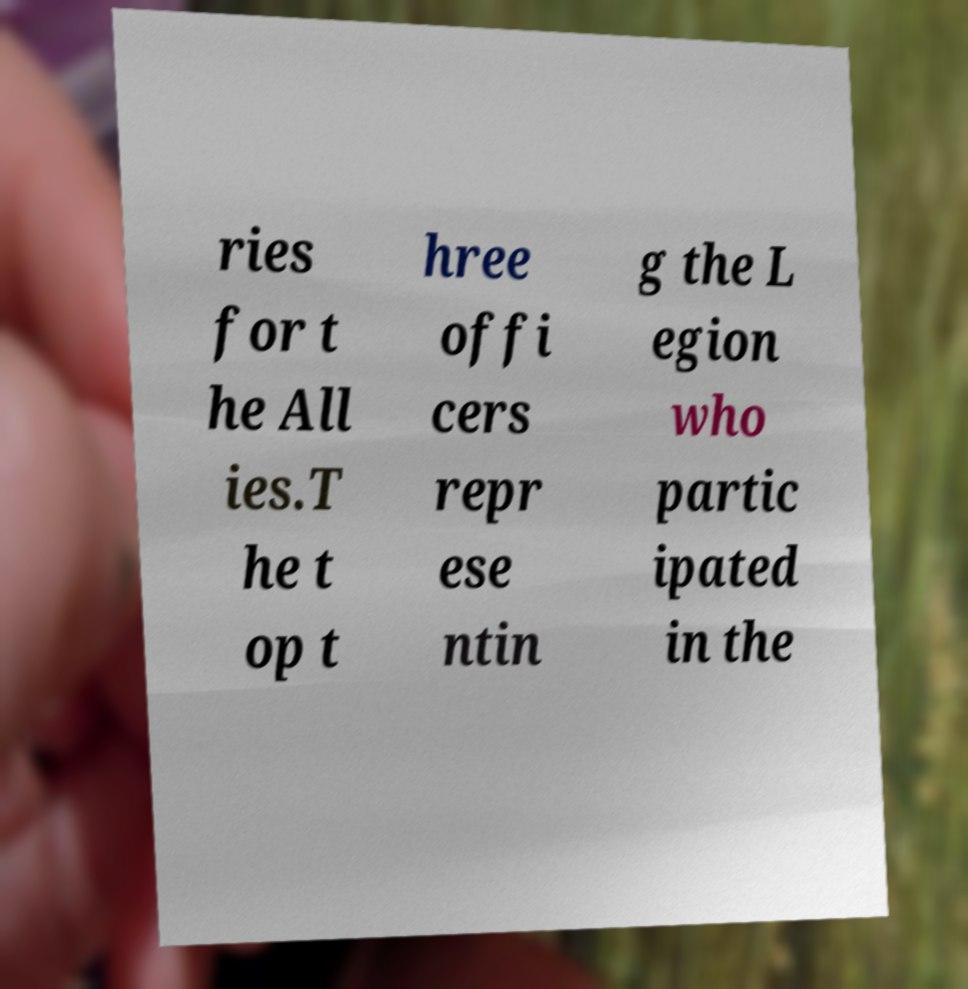For documentation purposes, I need the text within this image transcribed. Could you provide that? ries for t he All ies.T he t op t hree offi cers repr ese ntin g the L egion who partic ipated in the 